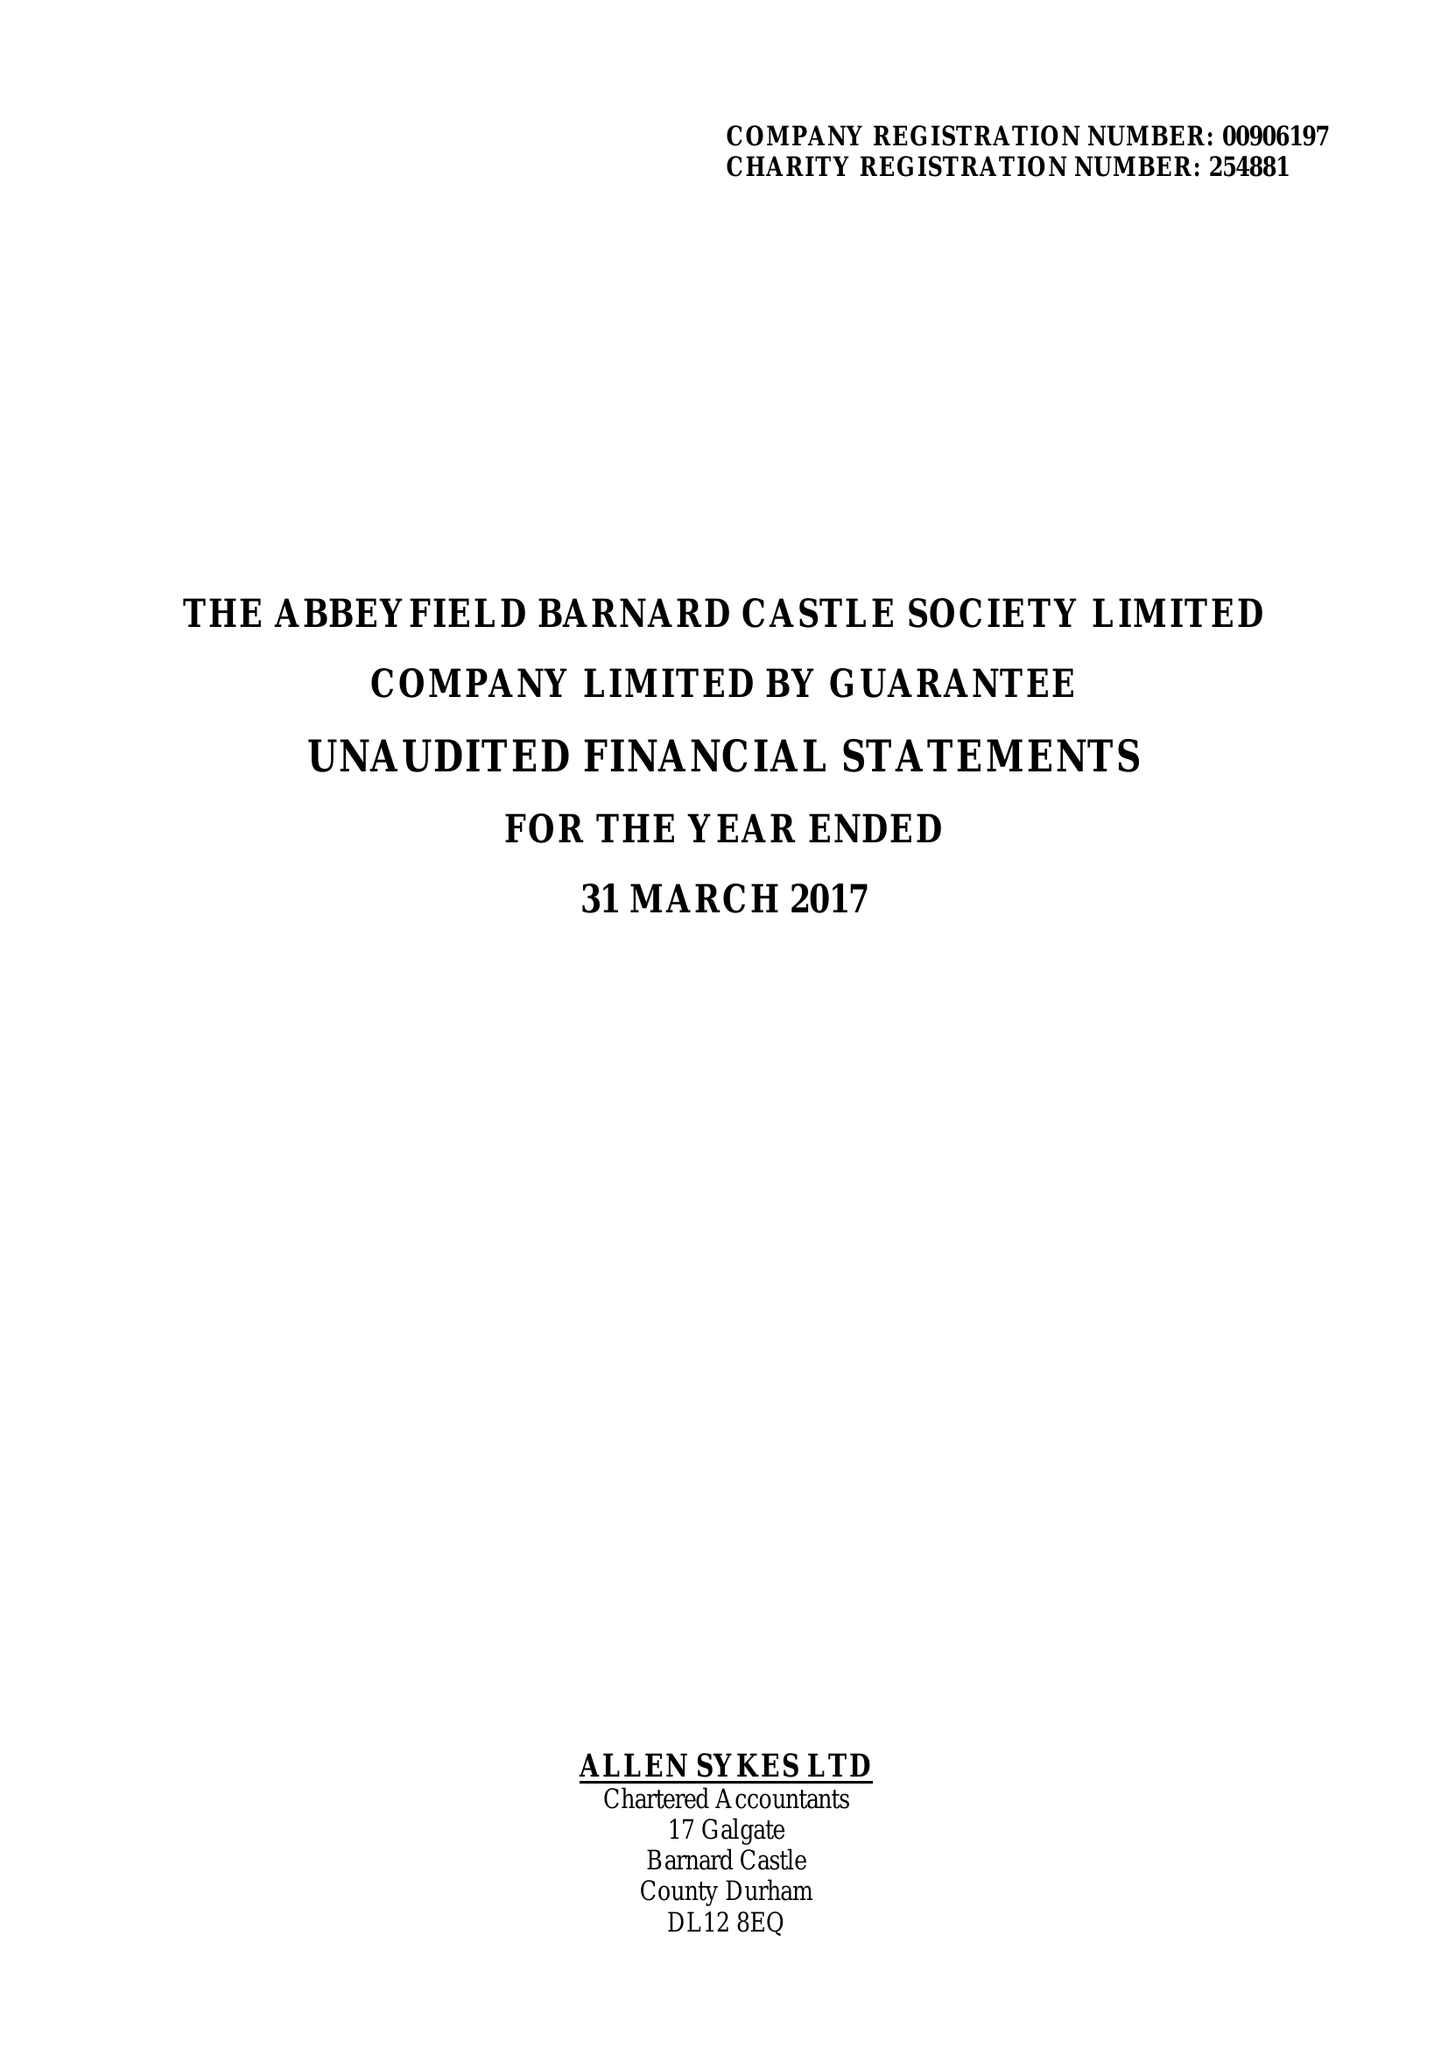What is the value for the charity_number?
Answer the question using a single word or phrase. 254881 